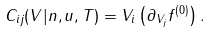Convert formula to latex. <formula><loc_0><loc_0><loc_500><loc_500>C _ { i j } ( { V } | n , { u } , T ) = V _ { i } \left ( \partial _ { V _ { j } } f ^ { ( 0 ) } \right ) .</formula> 